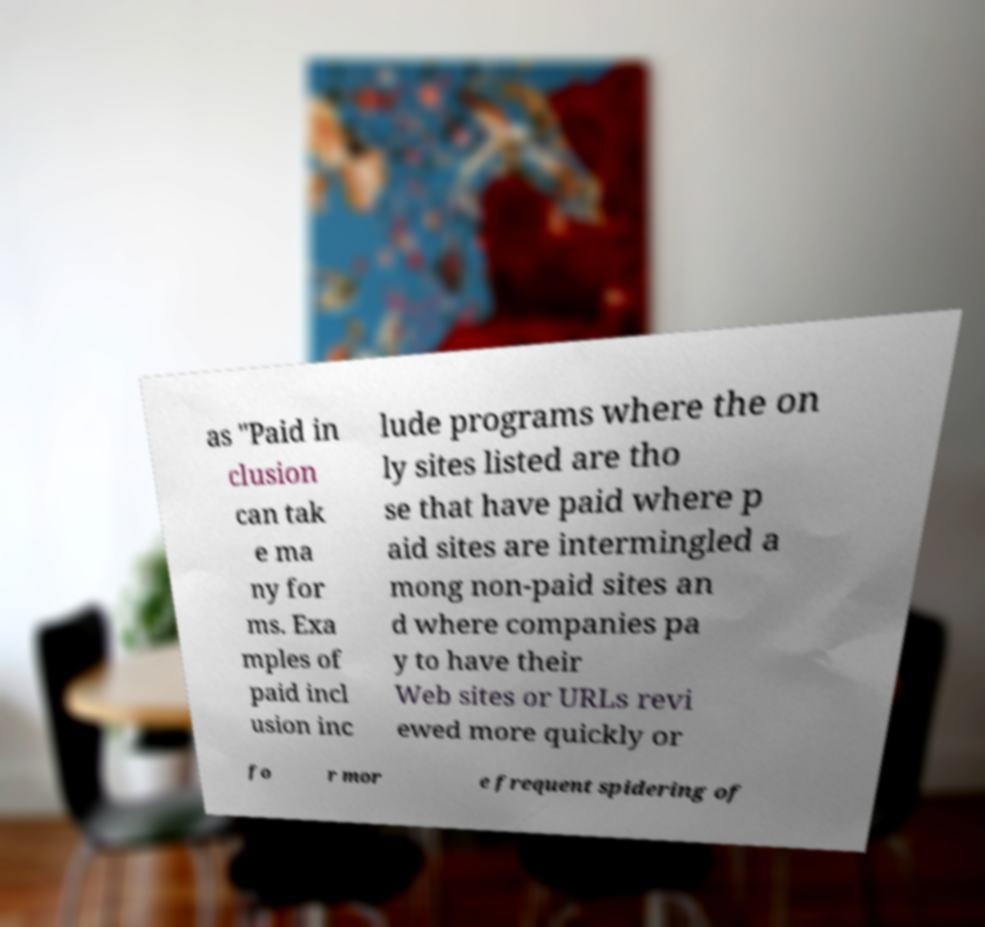There's text embedded in this image that I need extracted. Can you transcribe it verbatim? as "Paid in clusion can tak e ma ny for ms. Exa mples of paid incl usion inc lude programs where the on ly sites listed are tho se that have paid where p aid sites are intermingled a mong non-paid sites an d where companies pa y to have their Web sites or URLs revi ewed more quickly or fo r mor e frequent spidering of 